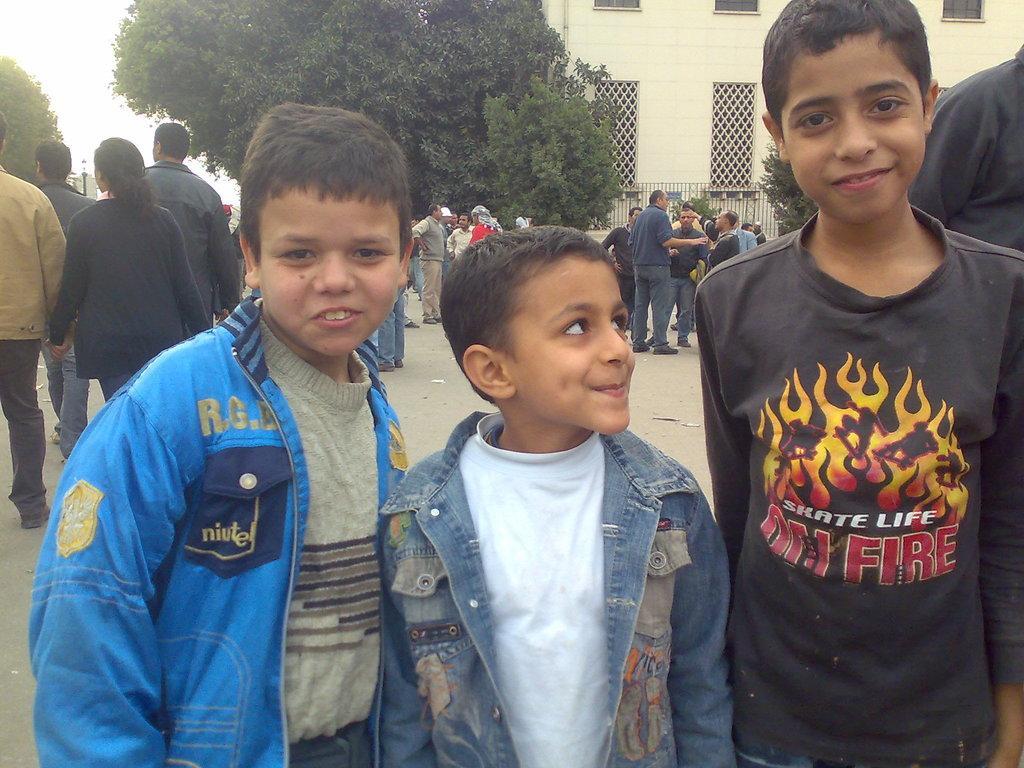Please provide a concise description of this image. In front of the image there are three kids with a smile on their face, behind them there are a few people standing, behind them there are trees, lamp posts and buildings with metal rod fence. 